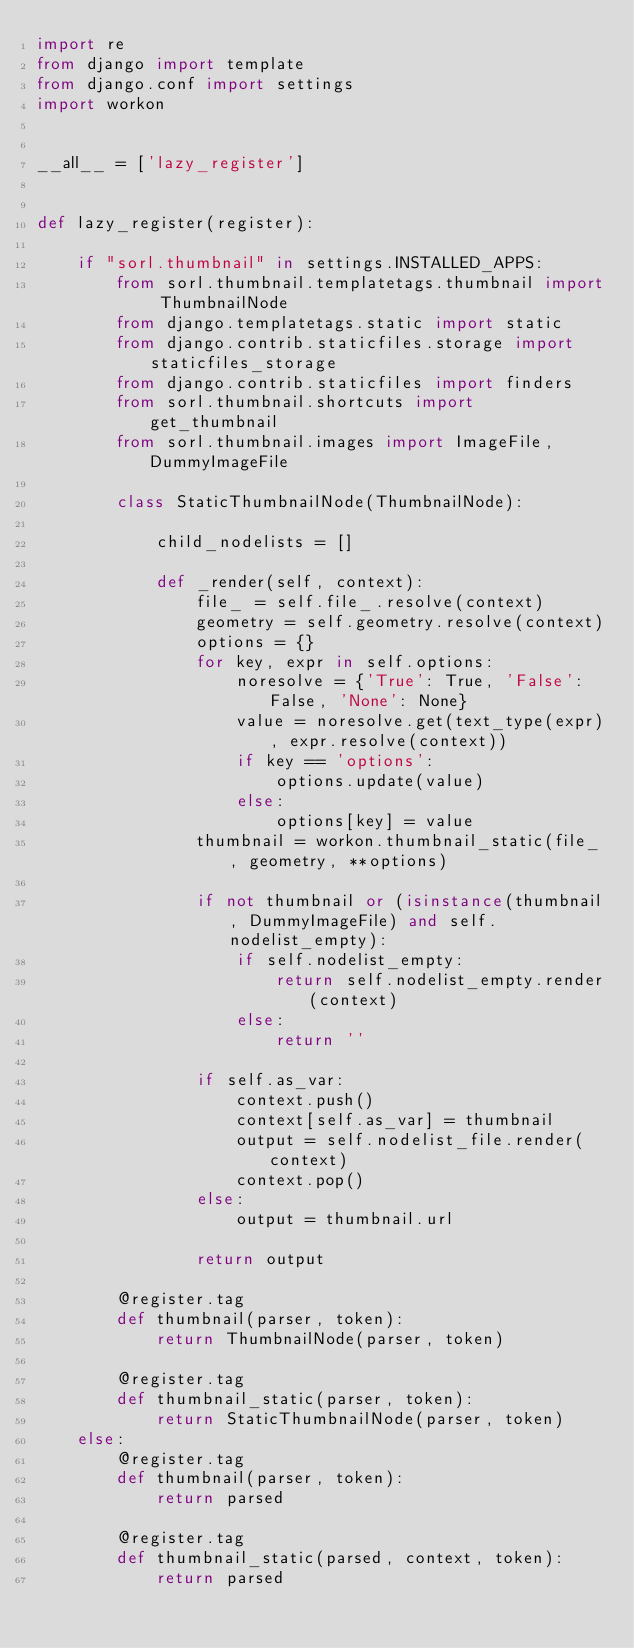<code> <loc_0><loc_0><loc_500><loc_500><_Python_>import re
from django import template
from django.conf import settings
import workon


__all__ = ['lazy_register']


def lazy_register(register):
    
    if "sorl.thumbnail" in settings.INSTALLED_APPS:
        from sorl.thumbnail.templatetags.thumbnail import ThumbnailNode
        from django.templatetags.static import static
        from django.contrib.staticfiles.storage import staticfiles_storage
        from django.contrib.staticfiles import finders
        from sorl.thumbnail.shortcuts import get_thumbnail
        from sorl.thumbnail.images import ImageFile, DummyImageFile

        class StaticThumbnailNode(ThumbnailNode):
            
            child_nodelists = []
            
            def _render(self, context):
                file_ = self.file_.resolve(context)
                geometry = self.geometry.resolve(context)
                options = {}
                for key, expr in self.options:
                    noresolve = {'True': True, 'False': False, 'None': None}
                    value = noresolve.get(text_type(expr), expr.resolve(context))
                    if key == 'options':
                        options.update(value)
                    else:
                        options[key] = value
                thumbnail = workon.thumbnail_static(file_, geometry, **options)

                if not thumbnail or (isinstance(thumbnail, DummyImageFile) and self.nodelist_empty):
                    if self.nodelist_empty:
                        return self.nodelist_empty.render(context)
                    else:
                        return ''

                if self.as_var:
                    context.push()
                    context[self.as_var] = thumbnail
                    output = self.nodelist_file.render(context)
                    context.pop()
                else:
                    output = thumbnail.url

                return output

        @register.tag
        def thumbnail(parser, token):
            return ThumbnailNode(parser, token)

        @register.tag
        def thumbnail_static(parser, token):
            return StaticThumbnailNode(parser, token)
    else:
        @register.tag
        def thumbnail(parser, token):
            return parsed

        @register.tag
        def thumbnail_static(parsed, context, token):
            return parsed</code> 